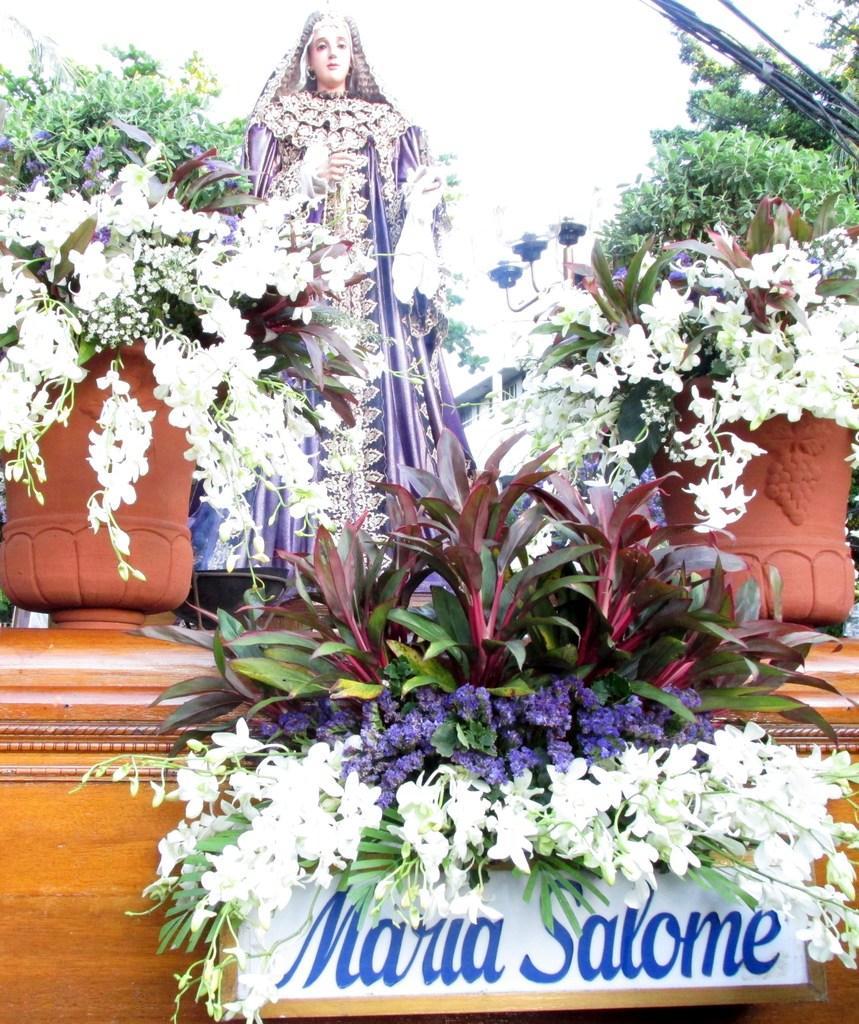Could you give a brief overview of what you see in this image? There are flowers, sculpture and trees at the back. 